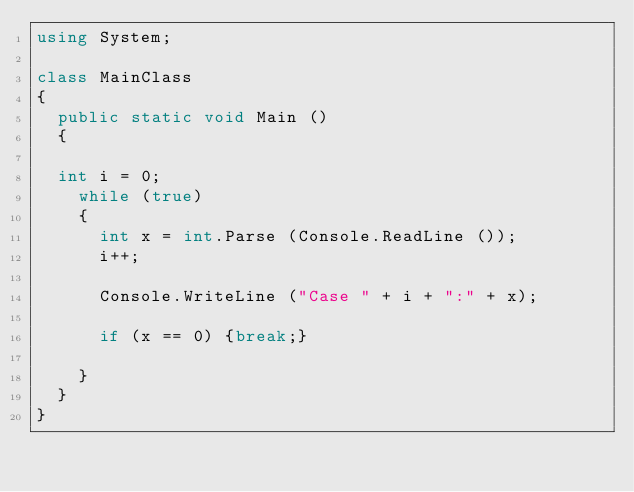Convert code to text. <code><loc_0><loc_0><loc_500><loc_500><_C#_>using System;

class MainClass
{
	public static void Main ()
	{
	
	int i = 0;
		while (true) 
		{
			int x = int.Parse (Console.ReadLine ());
			i++;

			Console.WriteLine ("Case " + i + ":" + x);

			if (x == 0) {break;}

		}
	}
}</code> 